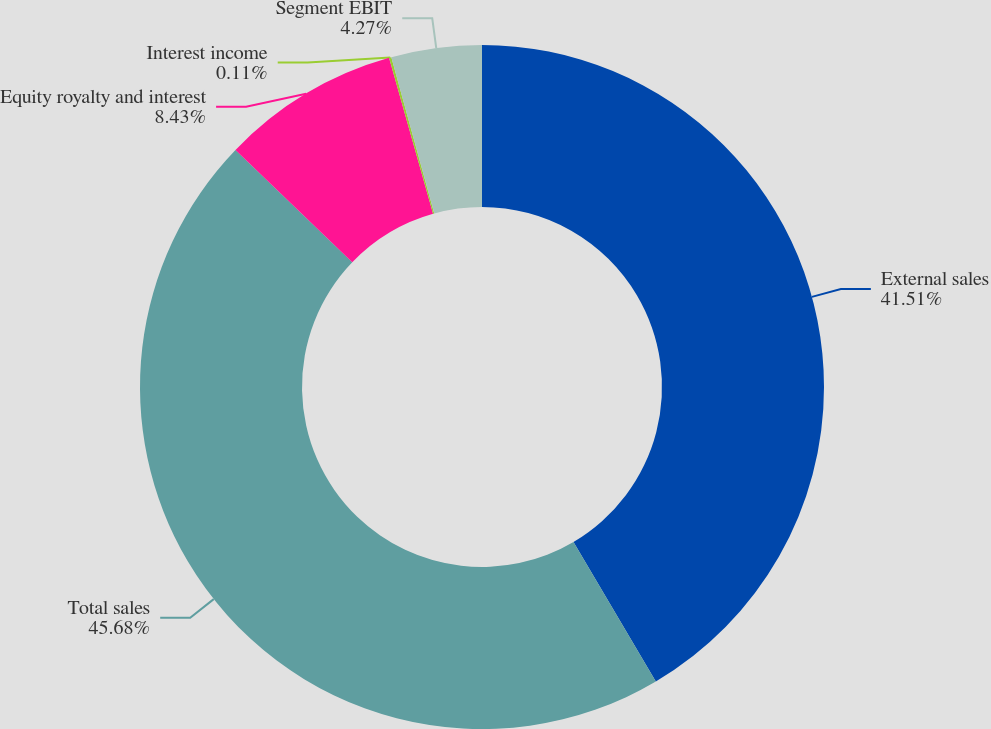<chart> <loc_0><loc_0><loc_500><loc_500><pie_chart><fcel>External sales<fcel>Total sales<fcel>Equity royalty and interest<fcel>Interest income<fcel>Segment EBIT<nl><fcel>41.51%<fcel>45.67%<fcel>8.43%<fcel>0.11%<fcel>4.27%<nl></chart> 